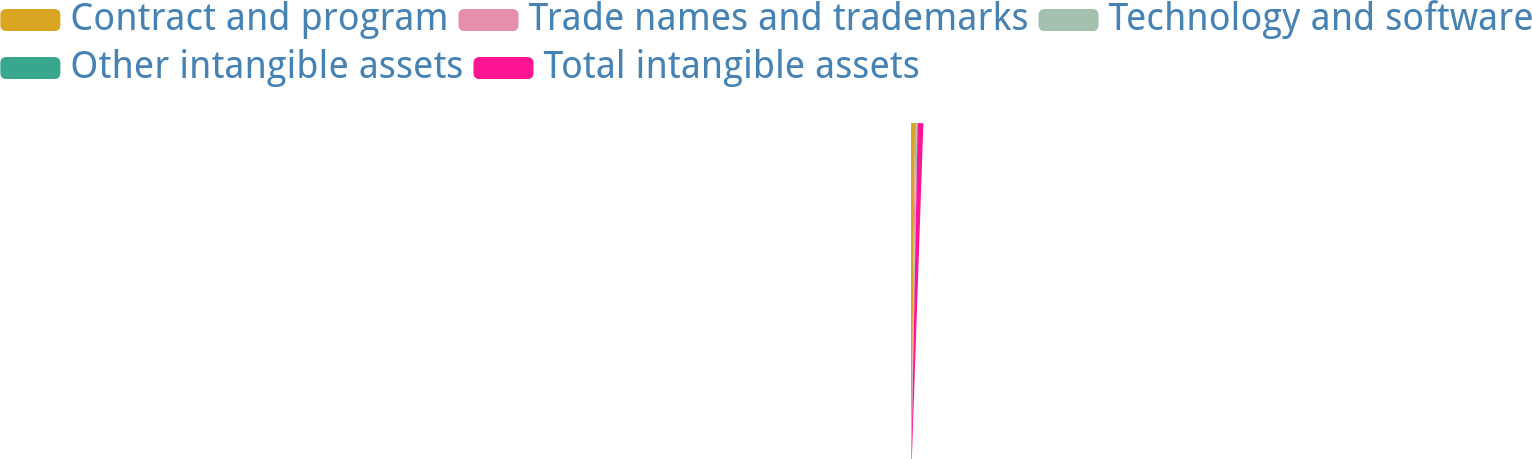Convert chart. <chart><loc_0><loc_0><loc_500><loc_500><pie_chart><fcel>Contract and program<fcel>Trade names and trademarks<fcel>Technology and software<fcel>Other intangible assets<fcel>Total intangible assets<nl><fcel>32.65%<fcel>11.43%<fcel>7.1%<fcel>2.77%<fcel>46.07%<nl></chart> 